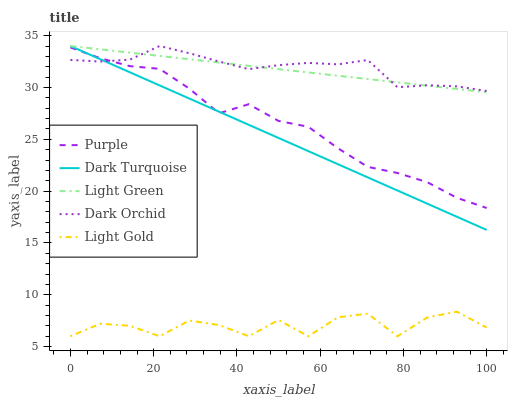Does Dark Turquoise have the minimum area under the curve?
Answer yes or no. No. Does Dark Turquoise have the maximum area under the curve?
Answer yes or no. No. Is Light Gold the smoothest?
Answer yes or no. No. Is Dark Turquoise the roughest?
Answer yes or no. No. Does Dark Turquoise have the lowest value?
Answer yes or no. No. Does Light Gold have the highest value?
Answer yes or no. No. Is Purple less than Light Green?
Answer yes or no. Yes. Is Light Green greater than Light Gold?
Answer yes or no. Yes. Does Purple intersect Light Green?
Answer yes or no. No. 